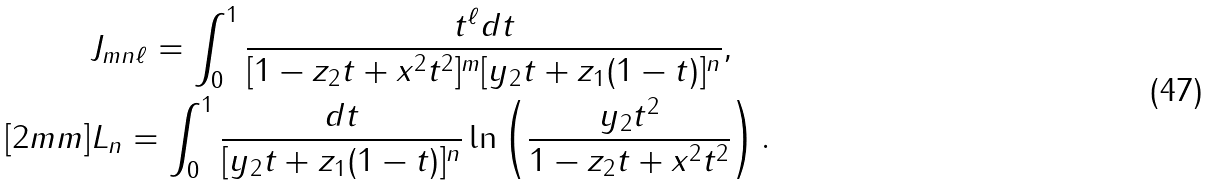Convert formula to latex. <formula><loc_0><loc_0><loc_500><loc_500>& J _ { m n \ell } = \int _ { 0 } ^ { 1 } \frac { t ^ { \ell } d t } { [ 1 - z _ { 2 } t + x ^ { 2 } t ^ { 2 } ] ^ { m } [ y _ { 2 } t + z _ { 1 } ( 1 - t ) ] ^ { n } } , \\ [ 2 m m ] & L _ { n } = \int _ { 0 } ^ { 1 } \frac { d t } { [ y _ { 2 } t + z _ { 1 } ( 1 - t ) ] ^ { n } } \ln \left ( \frac { y _ { 2 } t ^ { 2 } } { 1 - z _ { 2 } t + x ^ { 2 } t ^ { 2 } } \right ) .</formula> 